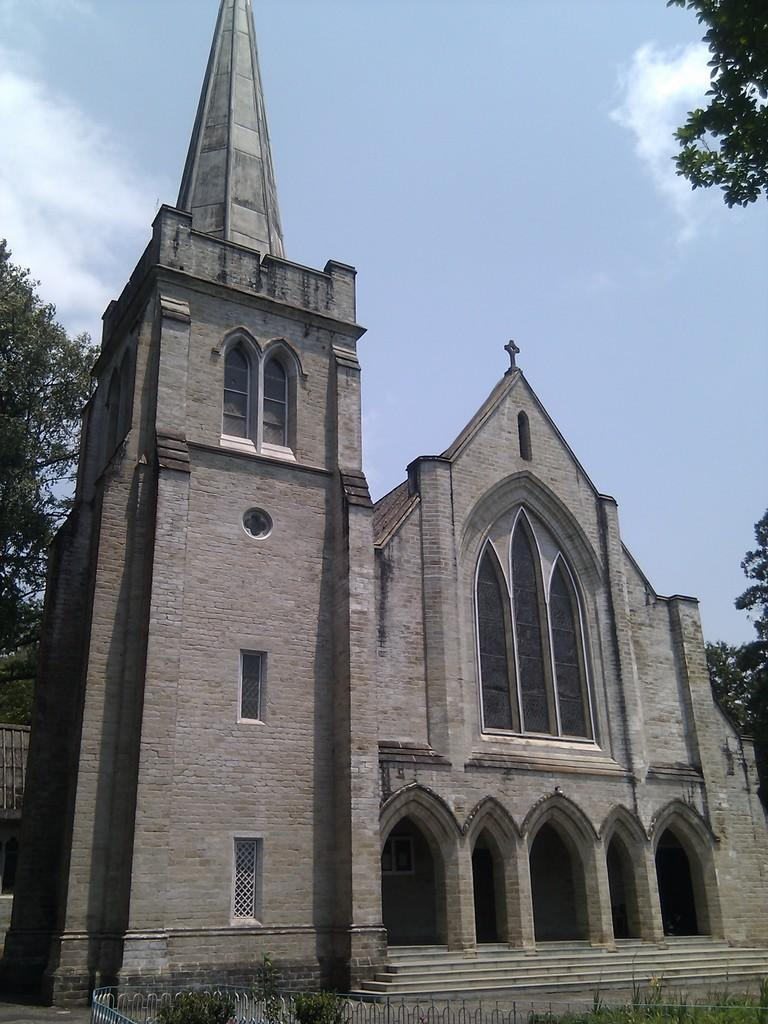What is the main structure visible in the image? There is a building in the image. What feature can be seen on the building? The building has windows. What type of vegetation is present on both sides of the image? There are trees on the left side of the image and trees on the right side of the image}. What is visible in the sky at the top of the image? There are clouds in the sky at the top of the image. Can you tell me how many cherries are on the building in the image? There are no cherries present on the building in the image. What advice does the mom give to the person in the image? There is no mom or person present in the image, so it is not possible to answer that question. 